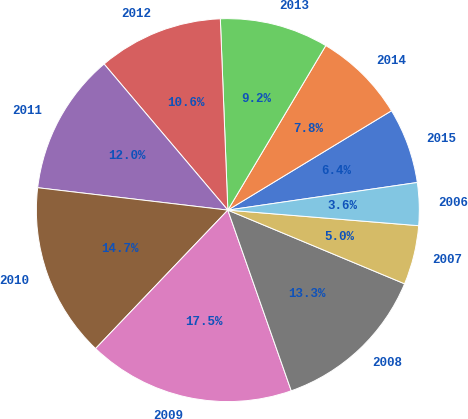Convert chart. <chart><loc_0><loc_0><loc_500><loc_500><pie_chart><fcel>2015<fcel>2014<fcel>2013<fcel>2012<fcel>2011<fcel>2010<fcel>2009<fcel>2008<fcel>2007<fcel>2006<nl><fcel>6.38%<fcel>7.77%<fcel>9.17%<fcel>10.56%<fcel>11.95%<fcel>14.73%<fcel>17.51%<fcel>13.34%<fcel>4.99%<fcel>3.6%<nl></chart> 